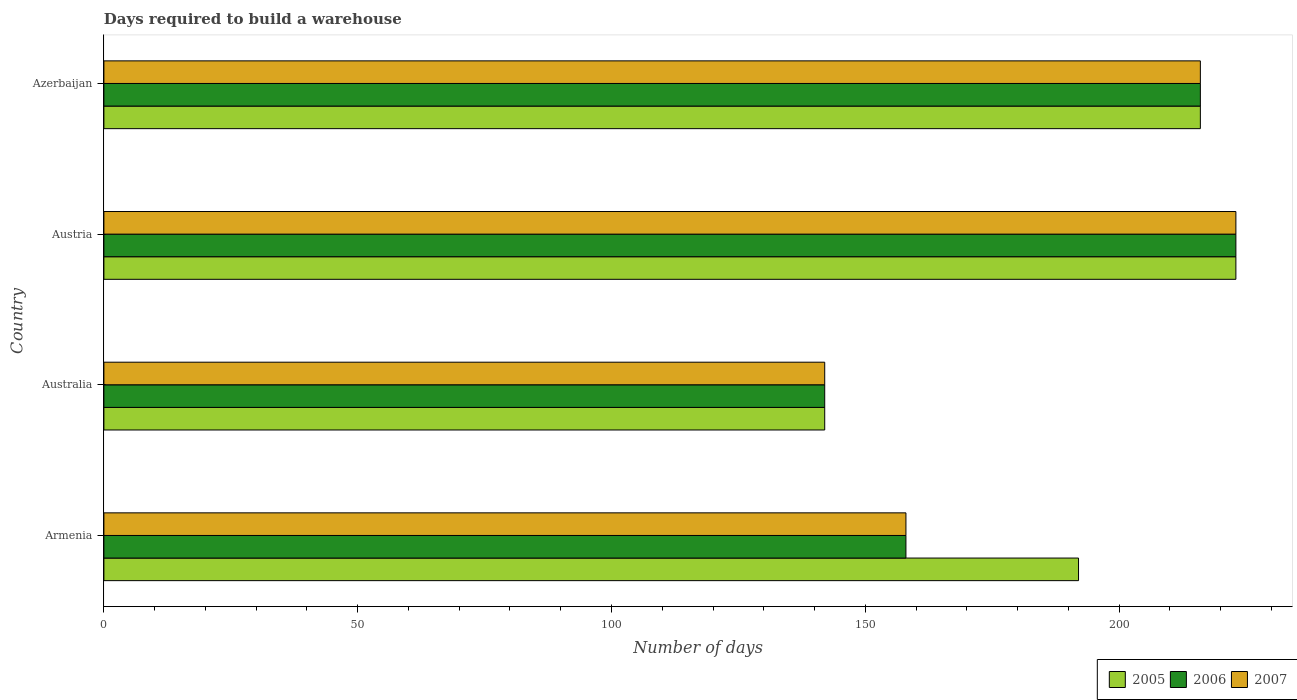Are the number of bars per tick equal to the number of legend labels?
Make the answer very short. Yes. How many bars are there on the 3rd tick from the bottom?
Offer a very short reply. 3. What is the label of the 4th group of bars from the top?
Provide a succinct answer. Armenia. What is the days required to build a warehouse in in 2005 in Austria?
Your response must be concise. 223. Across all countries, what is the maximum days required to build a warehouse in in 2007?
Provide a succinct answer. 223. Across all countries, what is the minimum days required to build a warehouse in in 2007?
Give a very brief answer. 142. In which country was the days required to build a warehouse in in 2006 minimum?
Offer a very short reply. Australia. What is the total days required to build a warehouse in in 2005 in the graph?
Give a very brief answer. 773. What is the difference between the days required to build a warehouse in in 2007 in Australia and that in Austria?
Your answer should be compact. -81. What is the difference between the days required to build a warehouse in in 2006 in Azerbaijan and the days required to build a warehouse in in 2007 in Australia?
Provide a succinct answer. 74. What is the average days required to build a warehouse in in 2006 per country?
Your answer should be very brief. 184.75. What is the ratio of the days required to build a warehouse in in 2005 in Australia to that in Azerbaijan?
Give a very brief answer. 0.66. Is the days required to build a warehouse in in 2007 in Armenia less than that in Australia?
Offer a terse response. No. Is the difference between the days required to build a warehouse in in 2005 in Austria and Azerbaijan greater than the difference between the days required to build a warehouse in in 2007 in Austria and Azerbaijan?
Provide a short and direct response. No. What is the difference between the highest and the lowest days required to build a warehouse in in 2007?
Offer a terse response. 81. What does the 2nd bar from the bottom in Azerbaijan represents?
Provide a short and direct response. 2006. Is it the case that in every country, the sum of the days required to build a warehouse in in 2005 and days required to build a warehouse in in 2006 is greater than the days required to build a warehouse in in 2007?
Offer a terse response. Yes. Does the graph contain any zero values?
Offer a very short reply. No. Does the graph contain grids?
Your answer should be compact. No. What is the title of the graph?
Ensure brevity in your answer.  Days required to build a warehouse. Does "1985" appear as one of the legend labels in the graph?
Your answer should be compact. No. What is the label or title of the X-axis?
Keep it short and to the point. Number of days. What is the label or title of the Y-axis?
Offer a very short reply. Country. What is the Number of days of 2005 in Armenia?
Offer a terse response. 192. What is the Number of days of 2006 in Armenia?
Ensure brevity in your answer.  158. What is the Number of days in 2007 in Armenia?
Ensure brevity in your answer.  158. What is the Number of days in 2005 in Australia?
Provide a succinct answer. 142. What is the Number of days in 2006 in Australia?
Provide a short and direct response. 142. What is the Number of days in 2007 in Australia?
Provide a short and direct response. 142. What is the Number of days in 2005 in Austria?
Offer a terse response. 223. What is the Number of days in 2006 in Austria?
Provide a succinct answer. 223. What is the Number of days in 2007 in Austria?
Ensure brevity in your answer.  223. What is the Number of days of 2005 in Azerbaijan?
Keep it short and to the point. 216. What is the Number of days in 2006 in Azerbaijan?
Offer a very short reply. 216. What is the Number of days of 2007 in Azerbaijan?
Your answer should be compact. 216. Across all countries, what is the maximum Number of days of 2005?
Offer a very short reply. 223. Across all countries, what is the maximum Number of days of 2006?
Ensure brevity in your answer.  223. Across all countries, what is the maximum Number of days in 2007?
Your answer should be compact. 223. Across all countries, what is the minimum Number of days in 2005?
Give a very brief answer. 142. Across all countries, what is the minimum Number of days in 2006?
Your response must be concise. 142. Across all countries, what is the minimum Number of days of 2007?
Offer a terse response. 142. What is the total Number of days in 2005 in the graph?
Make the answer very short. 773. What is the total Number of days in 2006 in the graph?
Offer a very short reply. 739. What is the total Number of days in 2007 in the graph?
Make the answer very short. 739. What is the difference between the Number of days in 2005 in Armenia and that in Australia?
Give a very brief answer. 50. What is the difference between the Number of days of 2006 in Armenia and that in Australia?
Offer a very short reply. 16. What is the difference between the Number of days in 2005 in Armenia and that in Austria?
Your answer should be very brief. -31. What is the difference between the Number of days in 2006 in Armenia and that in Austria?
Offer a very short reply. -65. What is the difference between the Number of days of 2007 in Armenia and that in Austria?
Provide a succinct answer. -65. What is the difference between the Number of days in 2006 in Armenia and that in Azerbaijan?
Ensure brevity in your answer.  -58. What is the difference between the Number of days of 2007 in Armenia and that in Azerbaijan?
Offer a terse response. -58. What is the difference between the Number of days of 2005 in Australia and that in Austria?
Provide a succinct answer. -81. What is the difference between the Number of days of 2006 in Australia and that in Austria?
Keep it short and to the point. -81. What is the difference between the Number of days in 2007 in Australia and that in Austria?
Make the answer very short. -81. What is the difference between the Number of days of 2005 in Australia and that in Azerbaijan?
Provide a short and direct response. -74. What is the difference between the Number of days of 2006 in Australia and that in Azerbaijan?
Your answer should be very brief. -74. What is the difference between the Number of days of 2007 in Australia and that in Azerbaijan?
Offer a very short reply. -74. What is the difference between the Number of days of 2005 in Armenia and the Number of days of 2006 in Australia?
Make the answer very short. 50. What is the difference between the Number of days of 2005 in Armenia and the Number of days of 2007 in Australia?
Your answer should be compact. 50. What is the difference between the Number of days of 2006 in Armenia and the Number of days of 2007 in Australia?
Your answer should be very brief. 16. What is the difference between the Number of days in 2005 in Armenia and the Number of days in 2006 in Austria?
Make the answer very short. -31. What is the difference between the Number of days in 2005 in Armenia and the Number of days in 2007 in Austria?
Offer a terse response. -31. What is the difference between the Number of days in 2006 in Armenia and the Number of days in 2007 in Austria?
Provide a succinct answer. -65. What is the difference between the Number of days in 2006 in Armenia and the Number of days in 2007 in Azerbaijan?
Offer a terse response. -58. What is the difference between the Number of days of 2005 in Australia and the Number of days of 2006 in Austria?
Your answer should be compact. -81. What is the difference between the Number of days of 2005 in Australia and the Number of days of 2007 in Austria?
Make the answer very short. -81. What is the difference between the Number of days of 2006 in Australia and the Number of days of 2007 in Austria?
Give a very brief answer. -81. What is the difference between the Number of days of 2005 in Australia and the Number of days of 2006 in Azerbaijan?
Provide a succinct answer. -74. What is the difference between the Number of days in 2005 in Australia and the Number of days in 2007 in Azerbaijan?
Ensure brevity in your answer.  -74. What is the difference between the Number of days of 2006 in Australia and the Number of days of 2007 in Azerbaijan?
Your response must be concise. -74. What is the average Number of days in 2005 per country?
Your answer should be compact. 193.25. What is the average Number of days in 2006 per country?
Your response must be concise. 184.75. What is the average Number of days in 2007 per country?
Your answer should be compact. 184.75. What is the difference between the Number of days of 2005 and Number of days of 2006 in Armenia?
Make the answer very short. 34. What is the difference between the Number of days of 2005 and Number of days of 2007 in Armenia?
Make the answer very short. 34. What is the difference between the Number of days in 2005 and Number of days in 2007 in Australia?
Provide a succinct answer. 0. What is the difference between the Number of days in 2006 and Number of days in 2007 in Australia?
Offer a very short reply. 0. What is the difference between the Number of days in 2005 and Number of days in 2006 in Austria?
Your answer should be compact. 0. What is the difference between the Number of days of 2005 and Number of days of 2006 in Azerbaijan?
Provide a succinct answer. 0. What is the ratio of the Number of days of 2005 in Armenia to that in Australia?
Give a very brief answer. 1.35. What is the ratio of the Number of days in 2006 in Armenia to that in Australia?
Offer a terse response. 1.11. What is the ratio of the Number of days in 2007 in Armenia to that in Australia?
Provide a succinct answer. 1.11. What is the ratio of the Number of days of 2005 in Armenia to that in Austria?
Give a very brief answer. 0.86. What is the ratio of the Number of days in 2006 in Armenia to that in Austria?
Make the answer very short. 0.71. What is the ratio of the Number of days in 2007 in Armenia to that in Austria?
Keep it short and to the point. 0.71. What is the ratio of the Number of days of 2006 in Armenia to that in Azerbaijan?
Keep it short and to the point. 0.73. What is the ratio of the Number of days of 2007 in Armenia to that in Azerbaijan?
Your answer should be compact. 0.73. What is the ratio of the Number of days in 2005 in Australia to that in Austria?
Your answer should be very brief. 0.64. What is the ratio of the Number of days in 2006 in Australia to that in Austria?
Offer a very short reply. 0.64. What is the ratio of the Number of days in 2007 in Australia to that in Austria?
Ensure brevity in your answer.  0.64. What is the ratio of the Number of days in 2005 in Australia to that in Azerbaijan?
Provide a succinct answer. 0.66. What is the ratio of the Number of days of 2006 in Australia to that in Azerbaijan?
Provide a succinct answer. 0.66. What is the ratio of the Number of days of 2007 in Australia to that in Azerbaijan?
Ensure brevity in your answer.  0.66. What is the ratio of the Number of days in 2005 in Austria to that in Azerbaijan?
Keep it short and to the point. 1.03. What is the ratio of the Number of days of 2006 in Austria to that in Azerbaijan?
Keep it short and to the point. 1.03. What is the ratio of the Number of days of 2007 in Austria to that in Azerbaijan?
Your answer should be compact. 1.03. What is the difference between the highest and the second highest Number of days of 2005?
Offer a very short reply. 7. What is the difference between the highest and the second highest Number of days in 2006?
Offer a terse response. 7. What is the difference between the highest and the second highest Number of days in 2007?
Provide a short and direct response. 7. What is the difference between the highest and the lowest Number of days of 2006?
Offer a terse response. 81. What is the difference between the highest and the lowest Number of days of 2007?
Offer a very short reply. 81. 